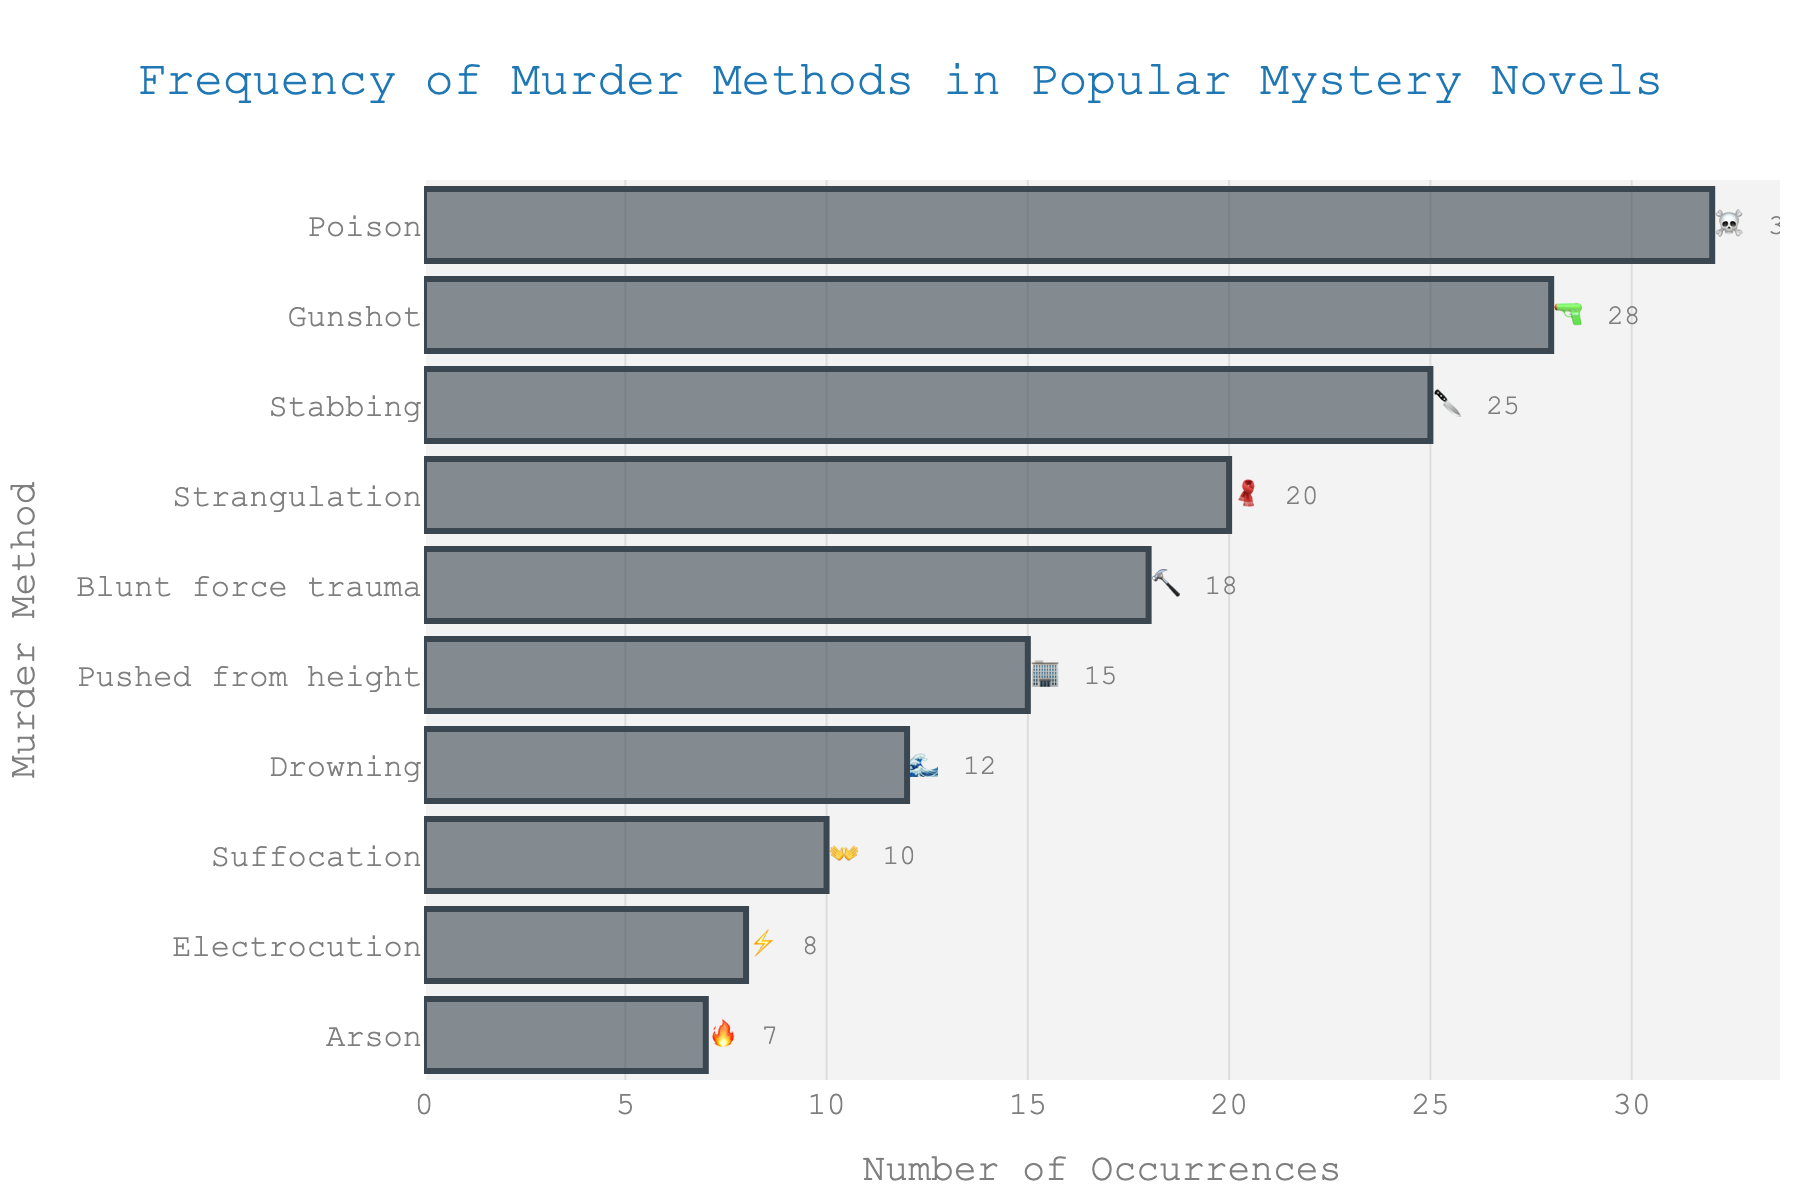What is the most common murder method in popular mystery novels? The bar chart shows the frequency of different murder methods. The method with the longest bar is the most common. "Poison" has the highest count of 32.
Answer: Poison How many methods have a count greater than 20? Count the bars with values higher than 20. "Poison", "Gunshot", "Stabbing", and "Strangulation" all have counts greater than 20.
Answer: 4 Which murder method is represented by the emoji 🔪? Look at the bar where the emoji is 🔪 and take note of the corresponding murder method, which is "Stabbing".
Answer: Stabbing What is the title of the chart? The title is usually found at the top of the chart. It reads "Frequency of Murder Methods in Popular Mystery Novels".
Answer: Frequency of Murder Methods in Popular Mystery Novels Which method is more frequent: Blunt force trauma or Drowning? Compare the counts beside the bars for "Blunt force trauma" (18) and "Drowning" (12). "Blunt force trauma" is more frequent.
Answer: Blunt force trauma How many murder methods have counts less than 10? Count the bars where the count is below 10. "Electrocution" (8) and "Arson" (7) have counts less than 10.
Answer: 2 What is the sum of the counts for the top three methods? The top three methods are "Poison", "Gunshot", and "Stabbing" with counts 32, 28, and 25. Adding them gives 32 + 28 + 25 = 85.
Answer: 85 Which murder method has the emoji 🌊 associated with it? Look for the emoji 🌊 and note its corresponding method, which is "Drowning".
Answer: Drowning Is there a murder method represented by an emoji with fewer than 5 counts? Scan each bar's count to see if any are less than 5. None of the counts are less than 5.
Answer: No How many more occurrences does Poison have than Blunt force trauma? Subtract the count for "Blunt force trauma" (18) from the count for "Poison" (32). 32 - 18 = 14.
Answer: 14 